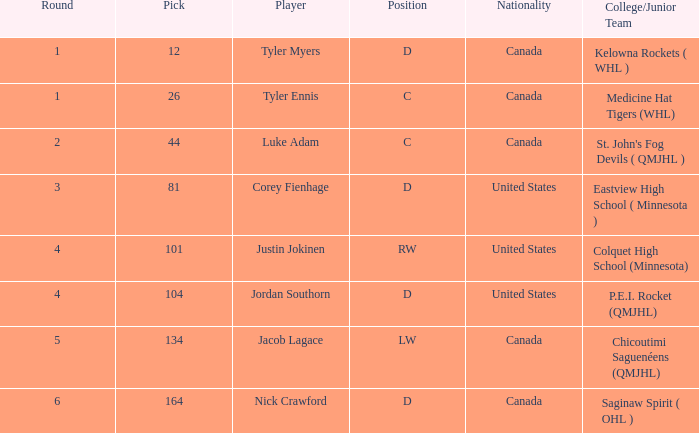What is the nationality of corey fienhage, the player with a pick under 104? United States. 